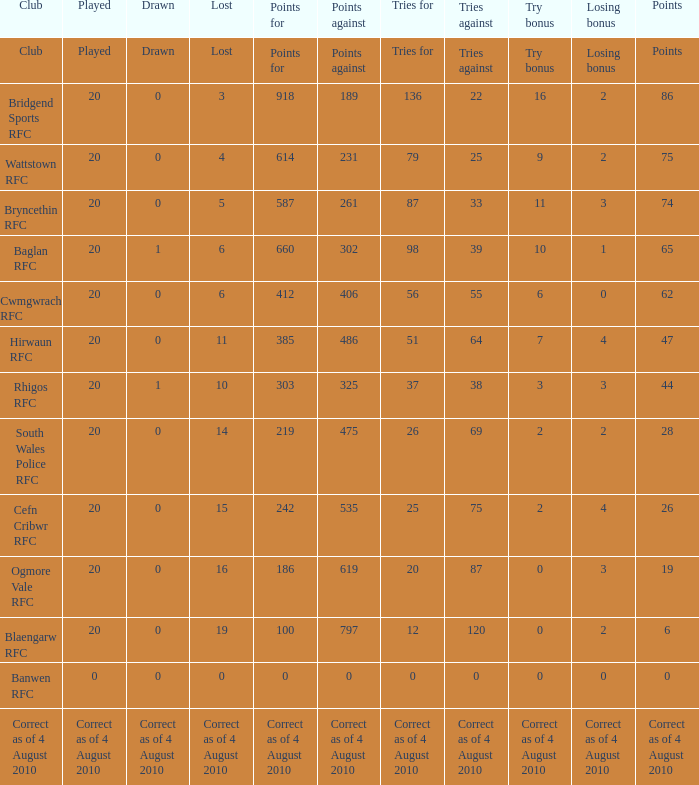What is sketched when the club is hirwaun rfc? 0.0. 